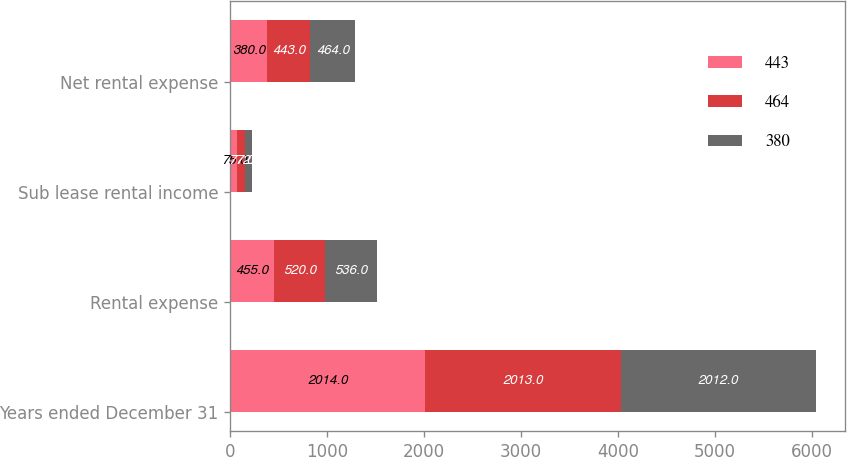Convert chart. <chart><loc_0><loc_0><loc_500><loc_500><stacked_bar_chart><ecel><fcel>Years ended December 31<fcel>Rental expense<fcel>Sub lease rental income<fcel>Net rental expense<nl><fcel>443<fcel>2014<fcel>455<fcel>75<fcel>380<nl><fcel>464<fcel>2013<fcel>520<fcel>77<fcel>443<nl><fcel>380<fcel>2012<fcel>536<fcel>72<fcel>464<nl></chart> 